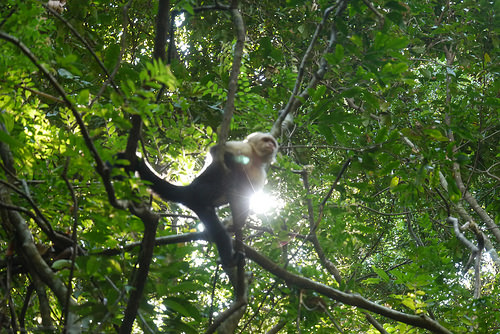<image>
Is there a monkey next to the sun? No. The monkey is not positioned next to the sun. They are located in different areas of the scene. 